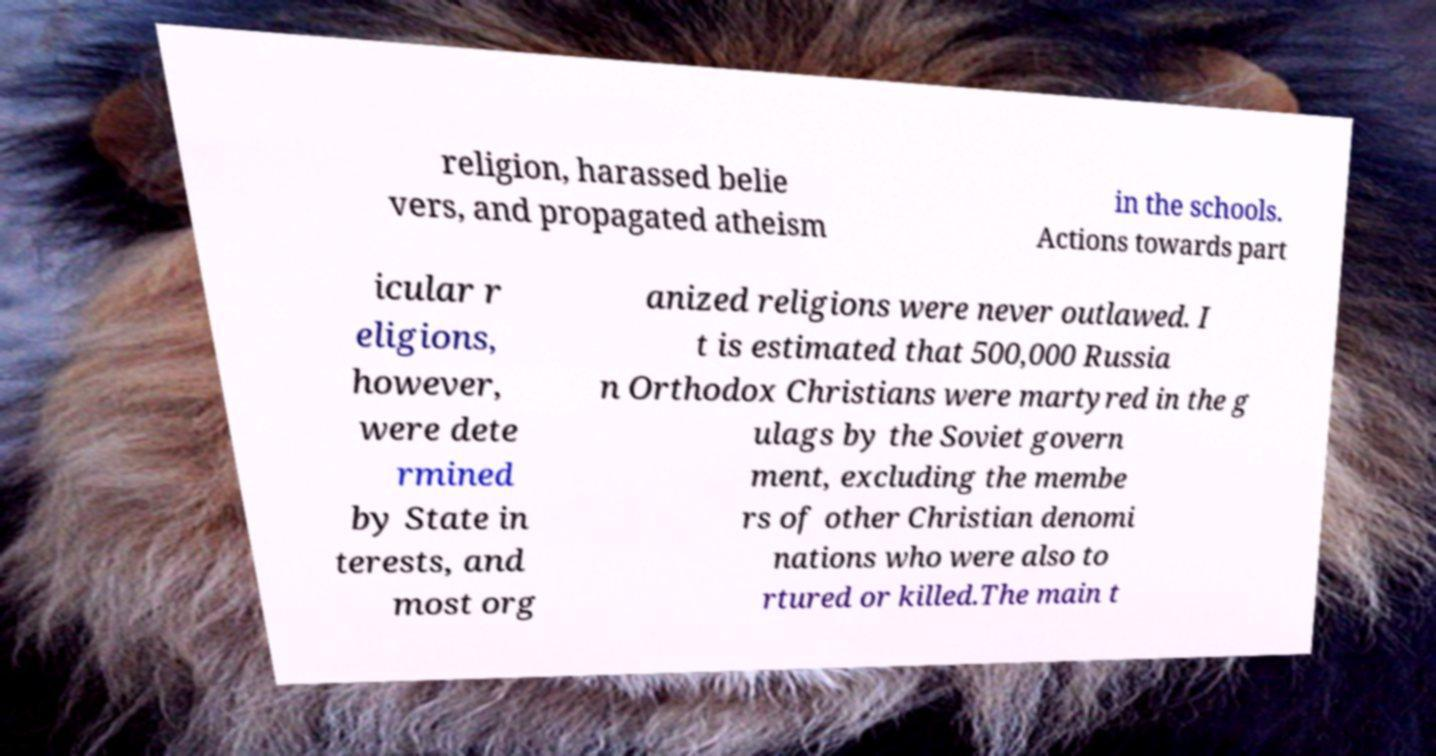Can you read and provide the text displayed in the image?This photo seems to have some interesting text. Can you extract and type it out for me? religion, harassed belie vers, and propagated atheism in the schools. Actions towards part icular r eligions, however, were dete rmined by State in terests, and most org anized religions were never outlawed. I t is estimated that 500,000 Russia n Orthodox Christians were martyred in the g ulags by the Soviet govern ment, excluding the membe rs of other Christian denomi nations who were also to rtured or killed.The main t 